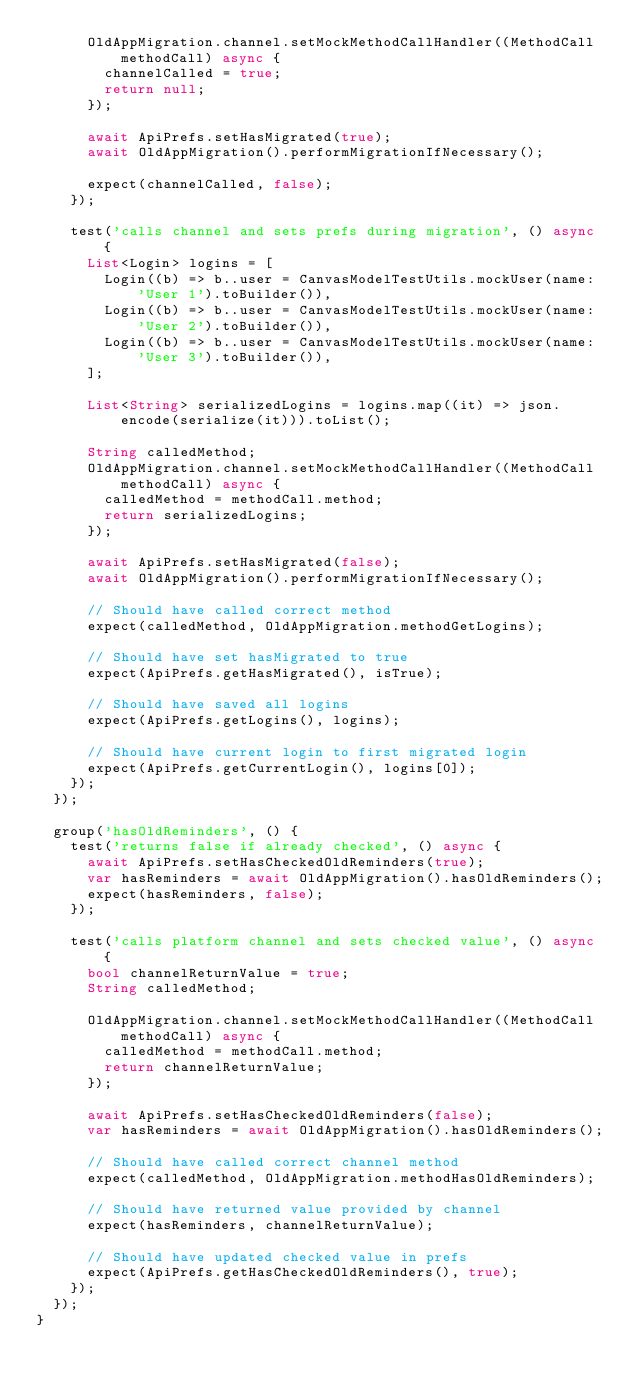<code> <loc_0><loc_0><loc_500><loc_500><_Dart_>      OldAppMigration.channel.setMockMethodCallHandler((MethodCall methodCall) async {
        channelCalled = true;
        return null;
      });

      await ApiPrefs.setHasMigrated(true);
      await OldAppMigration().performMigrationIfNecessary();

      expect(channelCalled, false);
    });

    test('calls channel and sets prefs during migration', () async {
      List<Login> logins = [
        Login((b) => b..user = CanvasModelTestUtils.mockUser(name: 'User 1').toBuilder()),
        Login((b) => b..user = CanvasModelTestUtils.mockUser(name: 'User 2').toBuilder()),
        Login((b) => b..user = CanvasModelTestUtils.mockUser(name: 'User 3').toBuilder()),
      ];

      List<String> serializedLogins = logins.map((it) => json.encode(serialize(it))).toList();

      String calledMethod;
      OldAppMigration.channel.setMockMethodCallHandler((MethodCall methodCall) async {
        calledMethod = methodCall.method;
        return serializedLogins;
      });

      await ApiPrefs.setHasMigrated(false);
      await OldAppMigration().performMigrationIfNecessary();

      // Should have called correct method
      expect(calledMethod, OldAppMigration.methodGetLogins);

      // Should have set hasMigrated to true
      expect(ApiPrefs.getHasMigrated(), isTrue);

      // Should have saved all logins
      expect(ApiPrefs.getLogins(), logins);

      // Should have current login to first migrated login
      expect(ApiPrefs.getCurrentLogin(), logins[0]);
    });
  });

  group('hasOldReminders', () {
    test('returns false if already checked', () async {
      await ApiPrefs.setHasCheckedOldReminders(true);
      var hasReminders = await OldAppMigration().hasOldReminders();
      expect(hasReminders, false);
    });

    test('calls platform channel and sets checked value', () async {
      bool channelReturnValue = true;
      String calledMethod;

      OldAppMigration.channel.setMockMethodCallHandler((MethodCall methodCall) async {
        calledMethod = methodCall.method;
        return channelReturnValue;
      });

      await ApiPrefs.setHasCheckedOldReminders(false);
      var hasReminders = await OldAppMigration().hasOldReminders();

      // Should have called correct channel method
      expect(calledMethod, OldAppMigration.methodHasOldReminders);

      // Should have returned value provided by channel
      expect(hasReminders, channelReturnValue);

      // Should have updated checked value in prefs
      expect(ApiPrefs.getHasCheckedOldReminders(), true);
    });
  });
}
</code> 